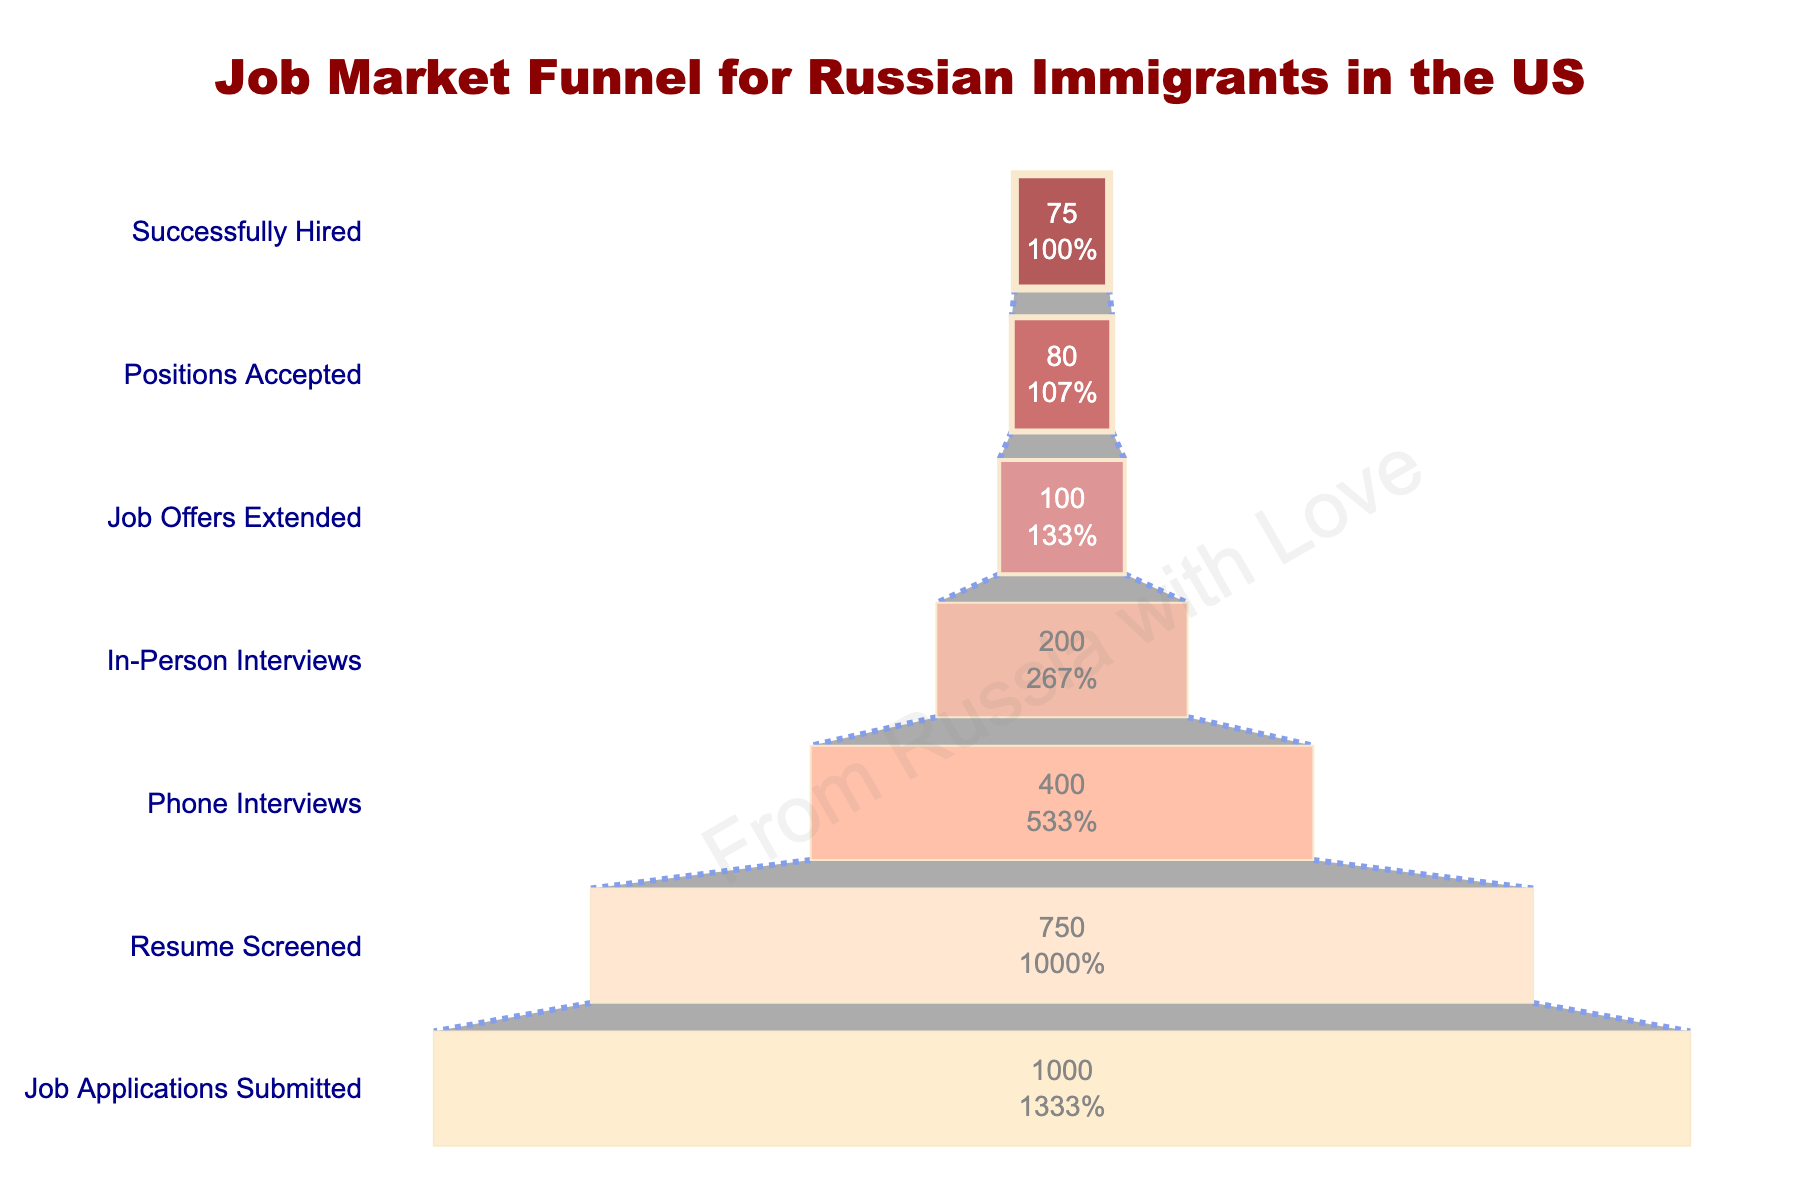what is the title of the plot? The title of the plot is located at the top-center of the figure and it is specified in a larger, bold font. It reads "Job Market Funnel for Russian Immigrants in the US".
Answer: Job Market Funnel for Russian Immigrants in the US How many job applications were submitted? The number of job applications submitted is shown at the top of the funnel and it is in the label "Job Applications Submitted". It shows a figure of 1000.
Answer: 1000 Which stage sees the highest number of applicants being filtered out? To determine which stage sees the highest number of applicants being filtered out, we look at the differences between each successive stage. The largest drop-off occurs from "Job Applications Submitted" (1000) to "Resume Screened" (750) with a decrease of 250 applicants.
Answer: Job Applications Submitted to Resume Screened What percentage of applicants actually get hired? We find the percentage by taking the number of applicants who 'Successfully Hired' (75) and divide it by the initial number of 'Job Applications Submitted' (1000), then multiply by 100: (75/1000)*100 = 7.5%.
Answer: 7.5% How many positions were accepted relative to the number of job offers extended? Look at the stages "Job Offers Extended" showing 100 and "Positions Accepted" showing 80. The difference is 20, indicating that 20 job offers were not accepted.
Answer: 80 out of 100 Between which two stages is the smallest decrease in the number of applicants? Identify the decrease by comparing the numbers between each successive stage. The smallest decrease is between "Positions Accepted" (80) and "Successfully Hired" (75), with a difference of only 5 applicants.
Answer: Positions Accepted to Successfully Hired What is the percentage of applicants that make it to the phone interview stage? To find the percentage of applicants who reach the phone interview stage, divide the number at "Phone Interviews" (400) by "Job Applications Submitted" (1000), then multiply by 100: (400/1000)*100 = 40%.
Answer: 40% By what percentage does the applicant pool reduce from phone interviews to in-person interviews? First, we find the number of applicants at each stage: "Phone Interviews" (400) and "In-Person Interviews" (200). The reduction is 400 - 200 = 200 applicants. To find the percentage reduction: (200/400) * 100 = 50%.
Answer: 50% What stages use the lightest color shade? The lightest shade is used for the final stages in the funnel. The shades get progressively lighter towards the bottom. The lightest colors are used for "Positions Accepted" and "Successfully Hired".
Answer: Positions Accepted and Successfully Hired How many total applicants make it past resume screening? We need the number of applicants starting from the "Resume Screened" stage onwards. "Resume Screened" shows 750 applicants who pass resume screening to further stages.
Answer: 750 